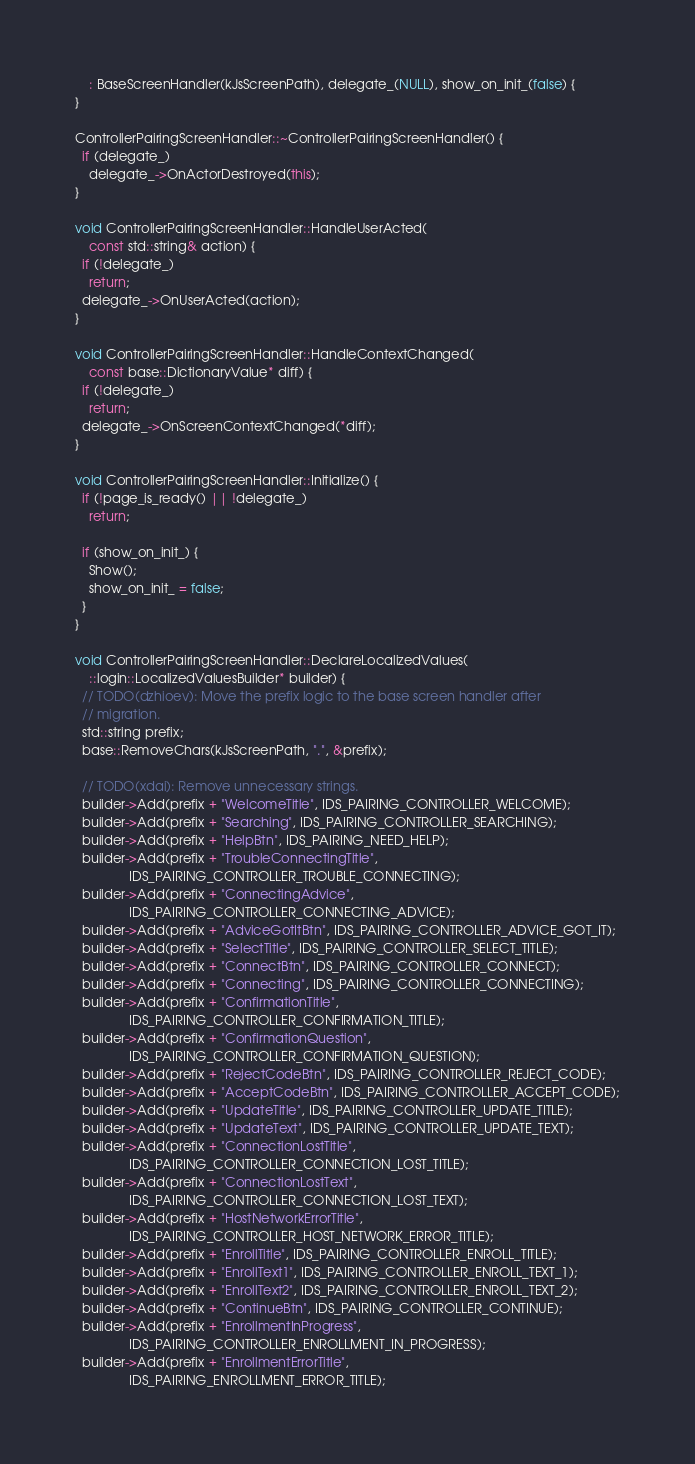<code> <loc_0><loc_0><loc_500><loc_500><_C++_>    : BaseScreenHandler(kJsScreenPath), delegate_(NULL), show_on_init_(false) {
}

ControllerPairingScreenHandler::~ControllerPairingScreenHandler() {
  if (delegate_)
    delegate_->OnActorDestroyed(this);
}

void ControllerPairingScreenHandler::HandleUserActed(
    const std::string& action) {
  if (!delegate_)
    return;
  delegate_->OnUserActed(action);
}

void ControllerPairingScreenHandler::HandleContextChanged(
    const base::DictionaryValue* diff) {
  if (!delegate_)
    return;
  delegate_->OnScreenContextChanged(*diff);
}

void ControllerPairingScreenHandler::Initialize() {
  if (!page_is_ready() || !delegate_)
    return;

  if (show_on_init_) {
    Show();
    show_on_init_ = false;
  }
}

void ControllerPairingScreenHandler::DeclareLocalizedValues(
    ::login::LocalizedValuesBuilder* builder) {
  // TODO(dzhioev): Move the prefix logic to the base screen handler after
  // migration.
  std::string prefix;
  base::RemoveChars(kJsScreenPath, ".", &prefix);

  // TODO(xdai): Remove unnecessary strings.
  builder->Add(prefix + "WelcomeTitle", IDS_PAIRING_CONTROLLER_WELCOME);
  builder->Add(prefix + "Searching", IDS_PAIRING_CONTROLLER_SEARCHING);
  builder->Add(prefix + "HelpBtn", IDS_PAIRING_NEED_HELP);
  builder->Add(prefix + "TroubleConnectingTitle",
               IDS_PAIRING_CONTROLLER_TROUBLE_CONNECTING);
  builder->Add(prefix + "ConnectingAdvice",
               IDS_PAIRING_CONTROLLER_CONNECTING_ADVICE);
  builder->Add(prefix + "AdviceGotItBtn", IDS_PAIRING_CONTROLLER_ADVICE_GOT_IT);
  builder->Add(prefix + "SelectTitle", IDS_PAIRING_CONTROLLER_SELECT_TITLE);
  builder->Add(prefix + "ConnectBtn", IDS_PAIRING_CONTROLLER_CONNECT);
  builder->Add(prefix + "Connecting", IDS_PAIRING_CONTROLLER_CONNECTING);
  builder->Add(prefix + "ConfirmationTitle",
               IDS_PAIRING_CONTROLLER_CONFIRMATION_TITLE);
  builder->Add(prefix + "ConfirmationQuestion",
               IDS_PAIRING_CONTROLLER_CONFIRMATION_QUESTION);
  builder->Add(prefix + "RejectCodeBtn", IDS_PAIRING_CONTROLLER_REJECT_CODE);
  builder->Add(prefix + "AcceptCodeBtn", IDS_PAIRING_CONTROLLER_ACCEPT_CODE);
  builder->Add(prefix + "UpdateTitle", IDS_PAIRING_CONTROLLER_UPDATE_TITLE);
  builder->Add(prefix + "UpdateText", IDS_PAIRING_CONTROLLER_UPDATE_TEXT);
  builder->Add(prefix + "ConnectionLostTitle",
               IDS_PAIRING_CONTROLLER_CONNECTION_LOST_TITLE);
  builder->Add(prefix + "ConnectionLostText",
               IDS_PAIRING_CONTROLLER_CONNECTION_LOST_TEXT);
  builder->Add(prefix + "HostNetworkErrorTitle",
               IDS_PAIRING_CONTROLLER_HOST_NETWORK_ERROR_TITLE);
  builder->Add(prefix + "EnrollTitle", IDS_PAIRING_CONTROLLER_ENROLL_TITLE);
  builder->Add(prefix + "EnrollText1", IDS_PAIRING_CONTROLLER_ENROLL_TEXT_1);
  builder->Add(prefix + "EnrollText2", IDS_PAIRING_CONTROLLER_ENROLL_TEXT_2);
  builder->Add(prefix + "ContinueBtn", IDS_PAIRING_CONTROLLER_CONTINUE);
  builder->Add(prefix + "EnrollmentInProgress",
               IDS_PAIRING_CONTROLLER_ENROLLMENT_IN_PROGRESS);
  builder->Add(prefix + "EnrollmentErrorTitle",
               IDS_PAIRING_ENROLLMENT_ERROR_TITLE);</code> 